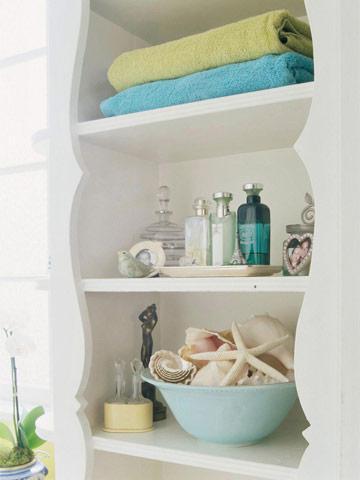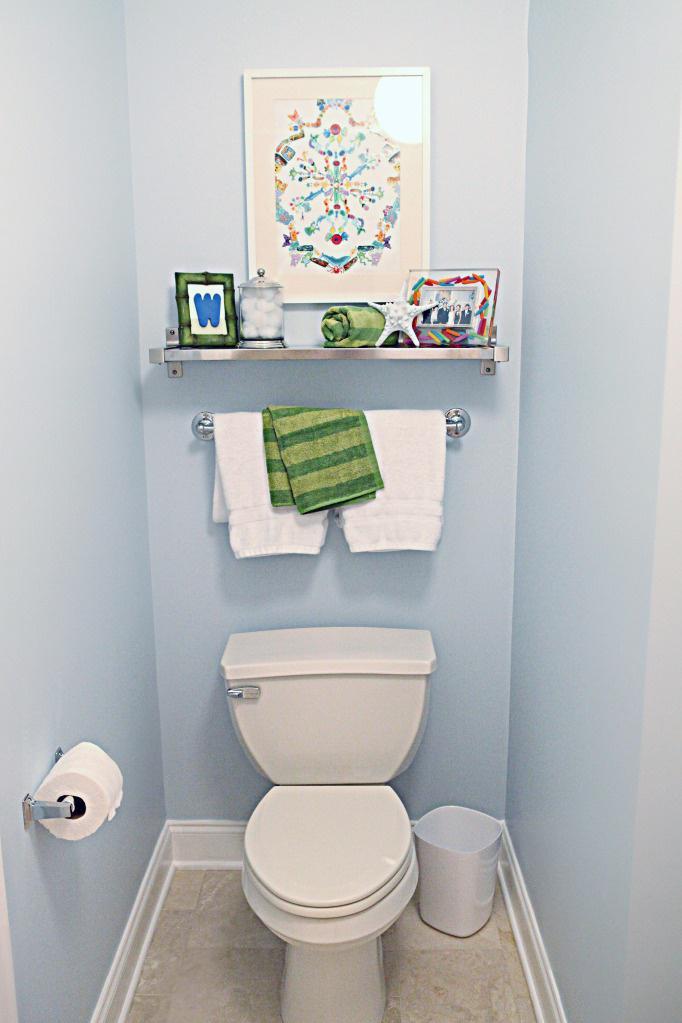The first image is the image on the left, the second image is the image on the right. Given the left and right images, does the statement "In at  least one image there are two sets of hand towels next to a striped shower curtain." hold true? Answer yes or no. No. The first image is the image on the left, the second image is the image on the right. Assess this claim about the two images: "One image features side-by-side white towels with smaller towels draped over them on a bar to the right of a shower.". Correct or not? Answer yes or no. No. 